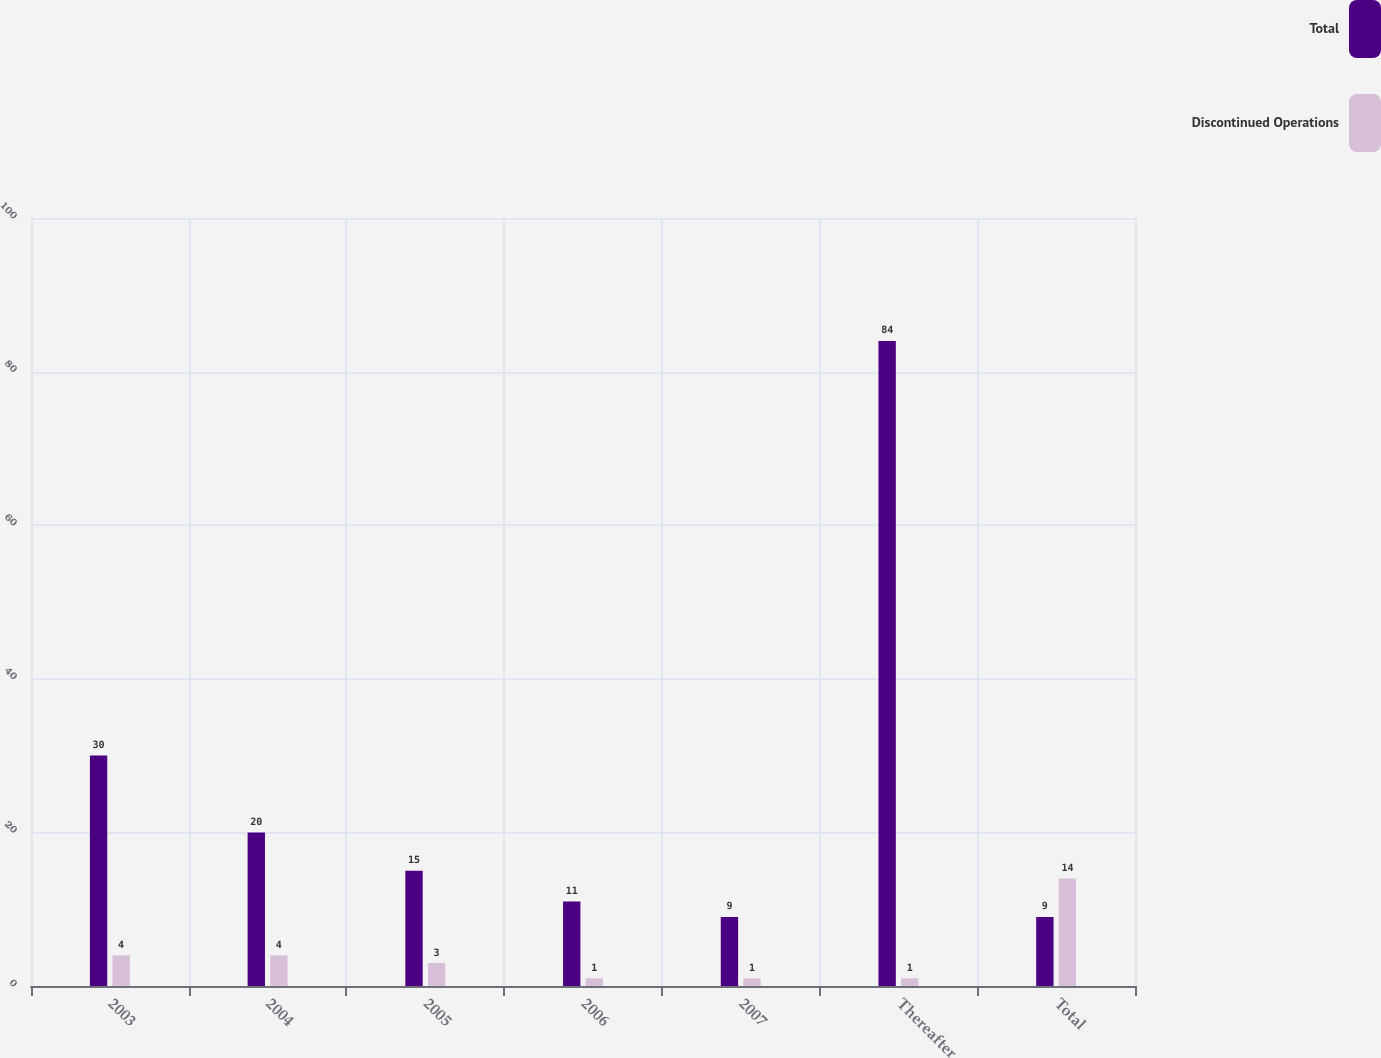<chart> <loc_0><loc_0><loc_500><loc_500><stacked_bar_chart><ecel><fcel>2003<fcel>2004<fcel>2005<fcel>2006<fcel>2007<fcel>Thereafter<fcel>Total<nl><fcel>Total<fcel>30<fcel>20<fcel>15<fcel>11<fcel>9<fcel>84<fcel>9<nl><fcel>Discontinued Operations<fcel>4<fcel>4<fcel>3<fcel>1<fcel>1<fcel>1<fcel>14<nl></chart> 